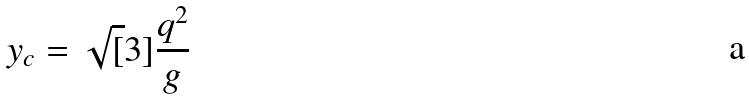<formula> <loc_0><loc_0><loc_500><loc_500>y _ { c } = \sqrt { [ } 3 ] { \frac { q ^ { 2 } } { g } }</formula> 